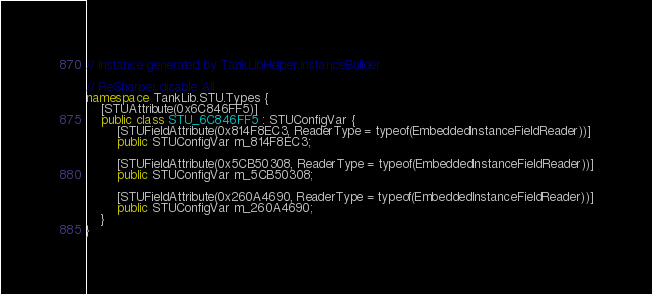Convert code to text. <code><loc_0><loc_0><loc_500><loc_500><_C#_>// Instance generated by TankLibHelper.InstanceBuilder

// ReSharper disable All
namespace TankLib.STU.Types {
    [STUAttribute(0x6C846FF5)]
    public class STU_6C846FF5 : STUConfigVar {
        [STUFieldAttribute(0x814F8EC3, ReaderType = typeof(EmbeddedInstanceFieldReader))]
        public STUConfigVar m_814F8EC3;

        [STUFieldAttribute(0x5CB50308, ReaderType = typeof(EmbeddedInstanceFieldReader))]
        public STUConfigVar m_5CB50308;

        [STUFieldAttribute(0x260A4690, ReaderType = typeof(EmbeddedInstanceFieldReader))]
        public STUConfigVar m_260A4690;
    }
}
</code> 